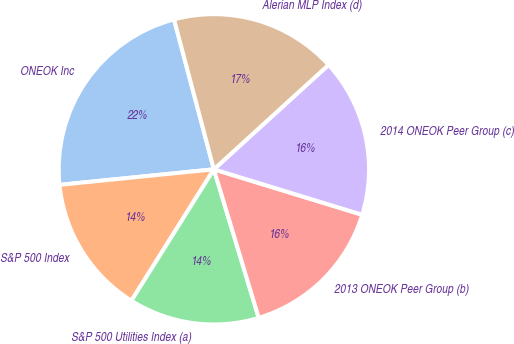Convert chart. <chart><loc_0><loc_0><loc_500><loc_500><pie_chart><fcel>ONEOK Inc<fcel>S&P 500 Index<fcel>S&P 500 Utilities Index (a)<fcel>2013 ONEOK Peer Group (b)<fcel>2014 ONEOK Peer Group (c)<fcel>Alerian MLP Index (d)<nl><fcel>22.46%<fcel>14.48%<fcel>13.59%<fcel>15.6%<fcel>16.49%<fcel>17.38%<nl></chart> 